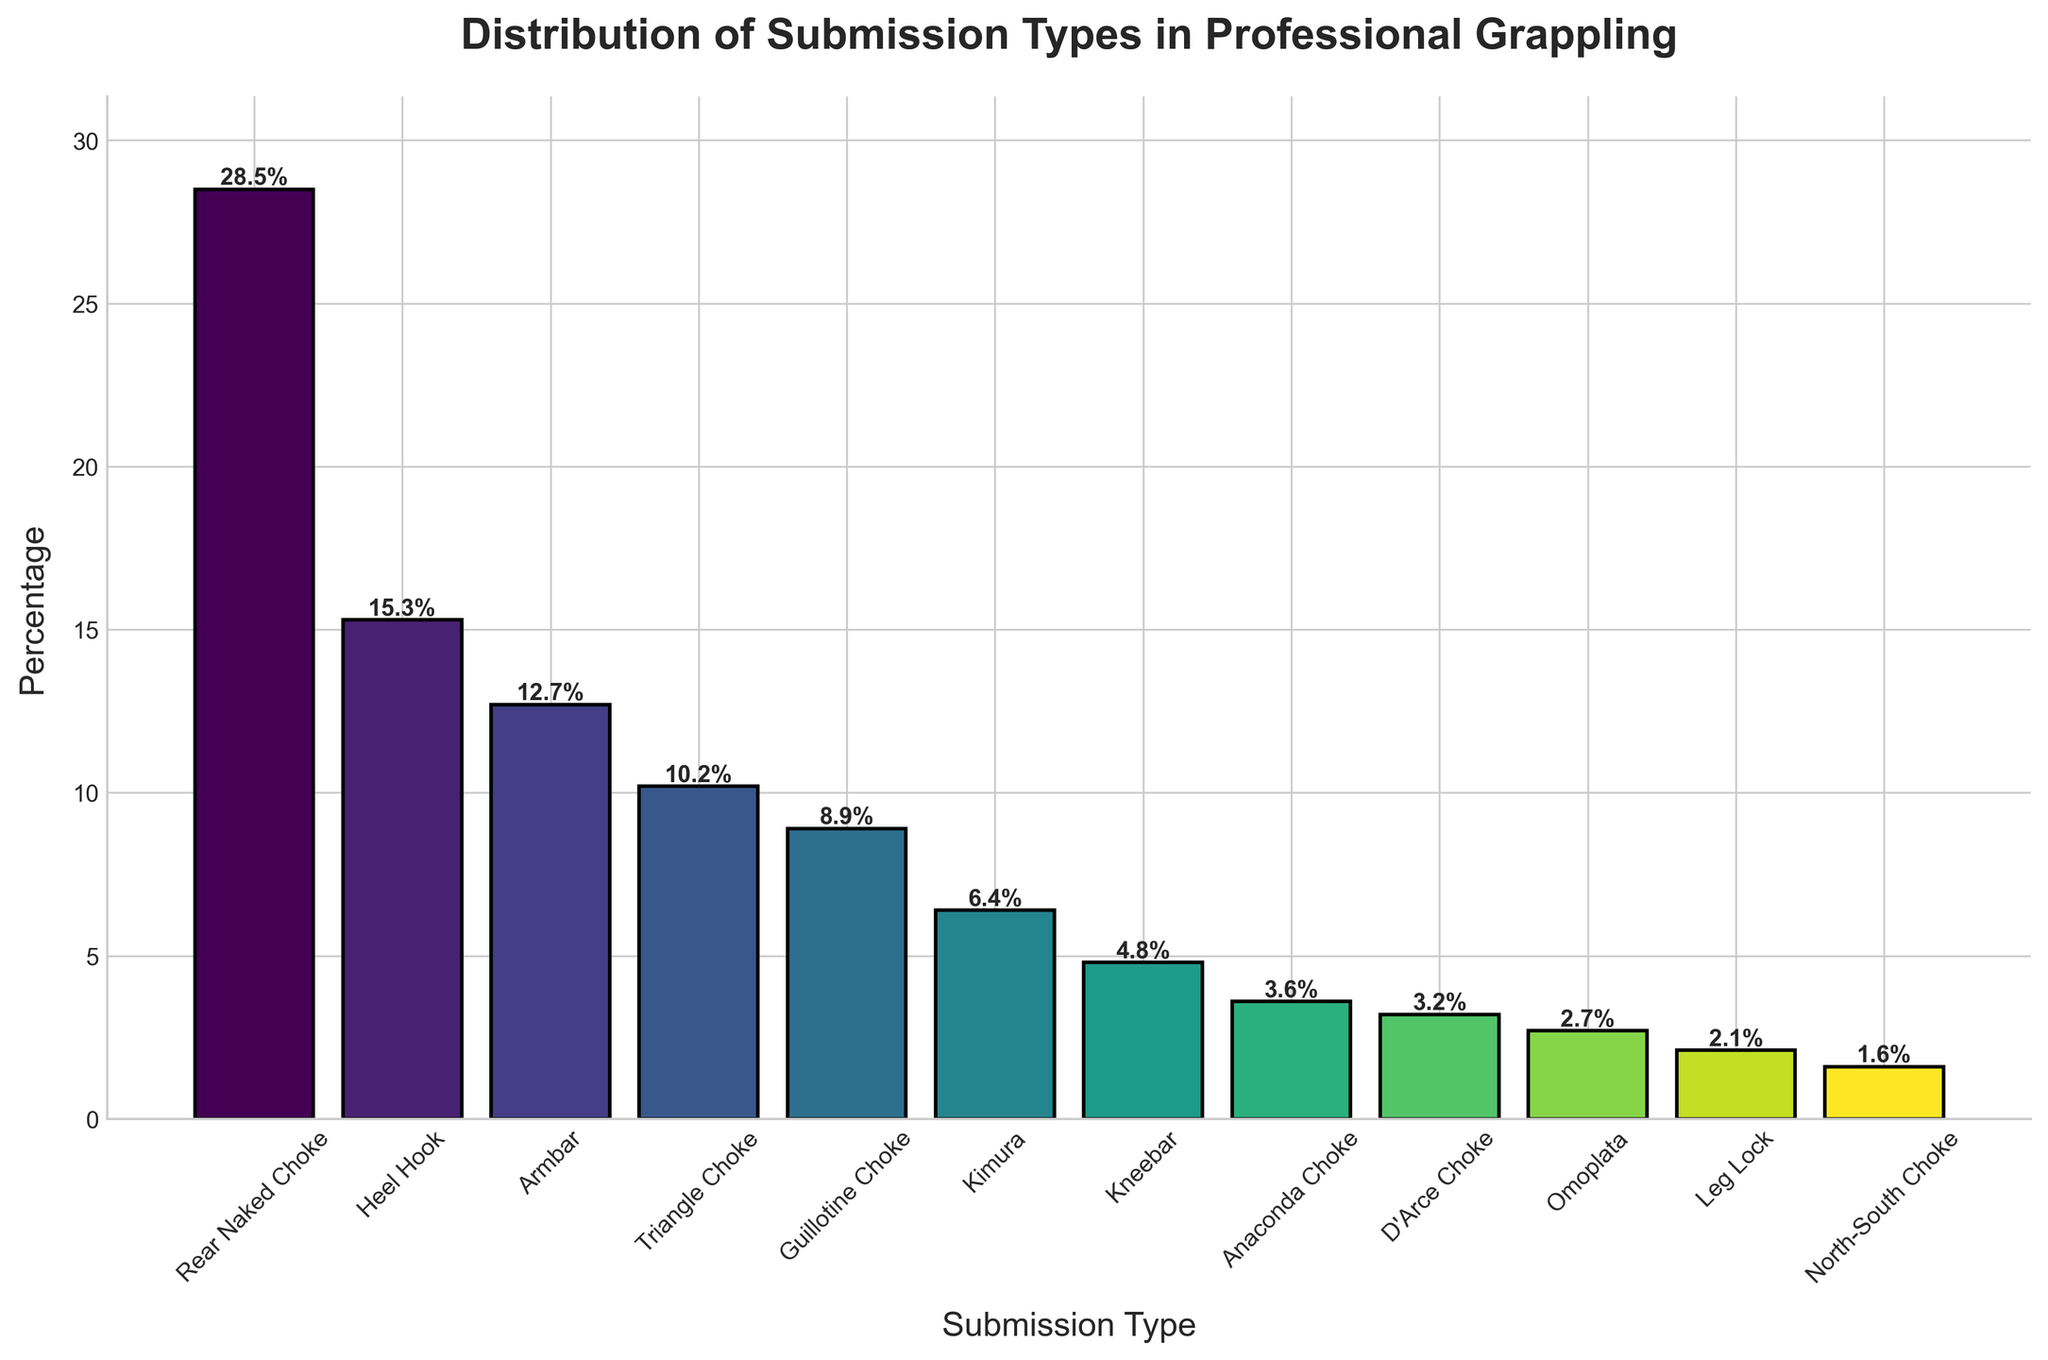What's the most common submission type? The tallest bar represents the Rear Naked Choke on the chart, indicating it has the highest percentage among the submission types.
Answer: Rear Naked Choke What percentage of submissions are accounted for by Armbar and Triangle Choke together? The bar heights for Armbar and Triangle Choke are 12.7% and 10.2%, respectively. Adding these percentages gives a total percentage of 22.9%.
Answer: 22.9% Which submission type is more common, Heel Hook or Guillotine Choke? The bar for Heel Hook is taller than the bar for Guillotine Choke. Heel Hook has a percentage of 15.3%, while Guillotine Choke has 8.9%.
Answer: Heel Hook What's the total percentage of submissions for the top three submission types? The top three submission types are Rear Naked Choke (28.5%), Heel Hook (15.3%), and Armbar (12.7%). Summing these gives 28.5 + 15.3 + 12.7 = 56.5%.
Answer: 56.5% Between Anaconda Choke and Omoplata, which has a smaller percentage? By visually comparing the bars, the bar for Omoplata is shorter than Anaconda Choke. Omoplata has a percentage of 2.7%, while Anaconda Choke has 3.6%.
Answer: Omoplata How much more common is the Rear Naked Choke compared to the North-South Choke? The percentage for Rear Naked Choke is 28.5%, and for North-South Choke, it is 1.6%. The difference is 28.5% - 1.6% = 26.9%.
Answer: 26.9% Which submission type has a percentage closest to 5%? By observing the bar heights, the Kimura has a percentage of 6.4%, which is closest to 5%.
Answer: Kimura Is the combined percentage for Heel Hook, Kimura, and Leg Lock greater than that of Rear Naked Choke? The combined percentage for Heel Hook, Kimura, and Leg Lock is 15.3 + 6.4 + 2.1 = 23.8%, while the percentage for Rear Naked Choke is 28.5%. 23.8% is less than 28.5%, so it is not greater.
Answer: No What are the shortest and tallest bars on the chart? The shortest bar is for the North-South Choke with a height of 1.6%, and the tallest bar is for the Rear Naked Choke with a height of 28.5%.
Answer: North-South Choke, Rear Naked Choke 